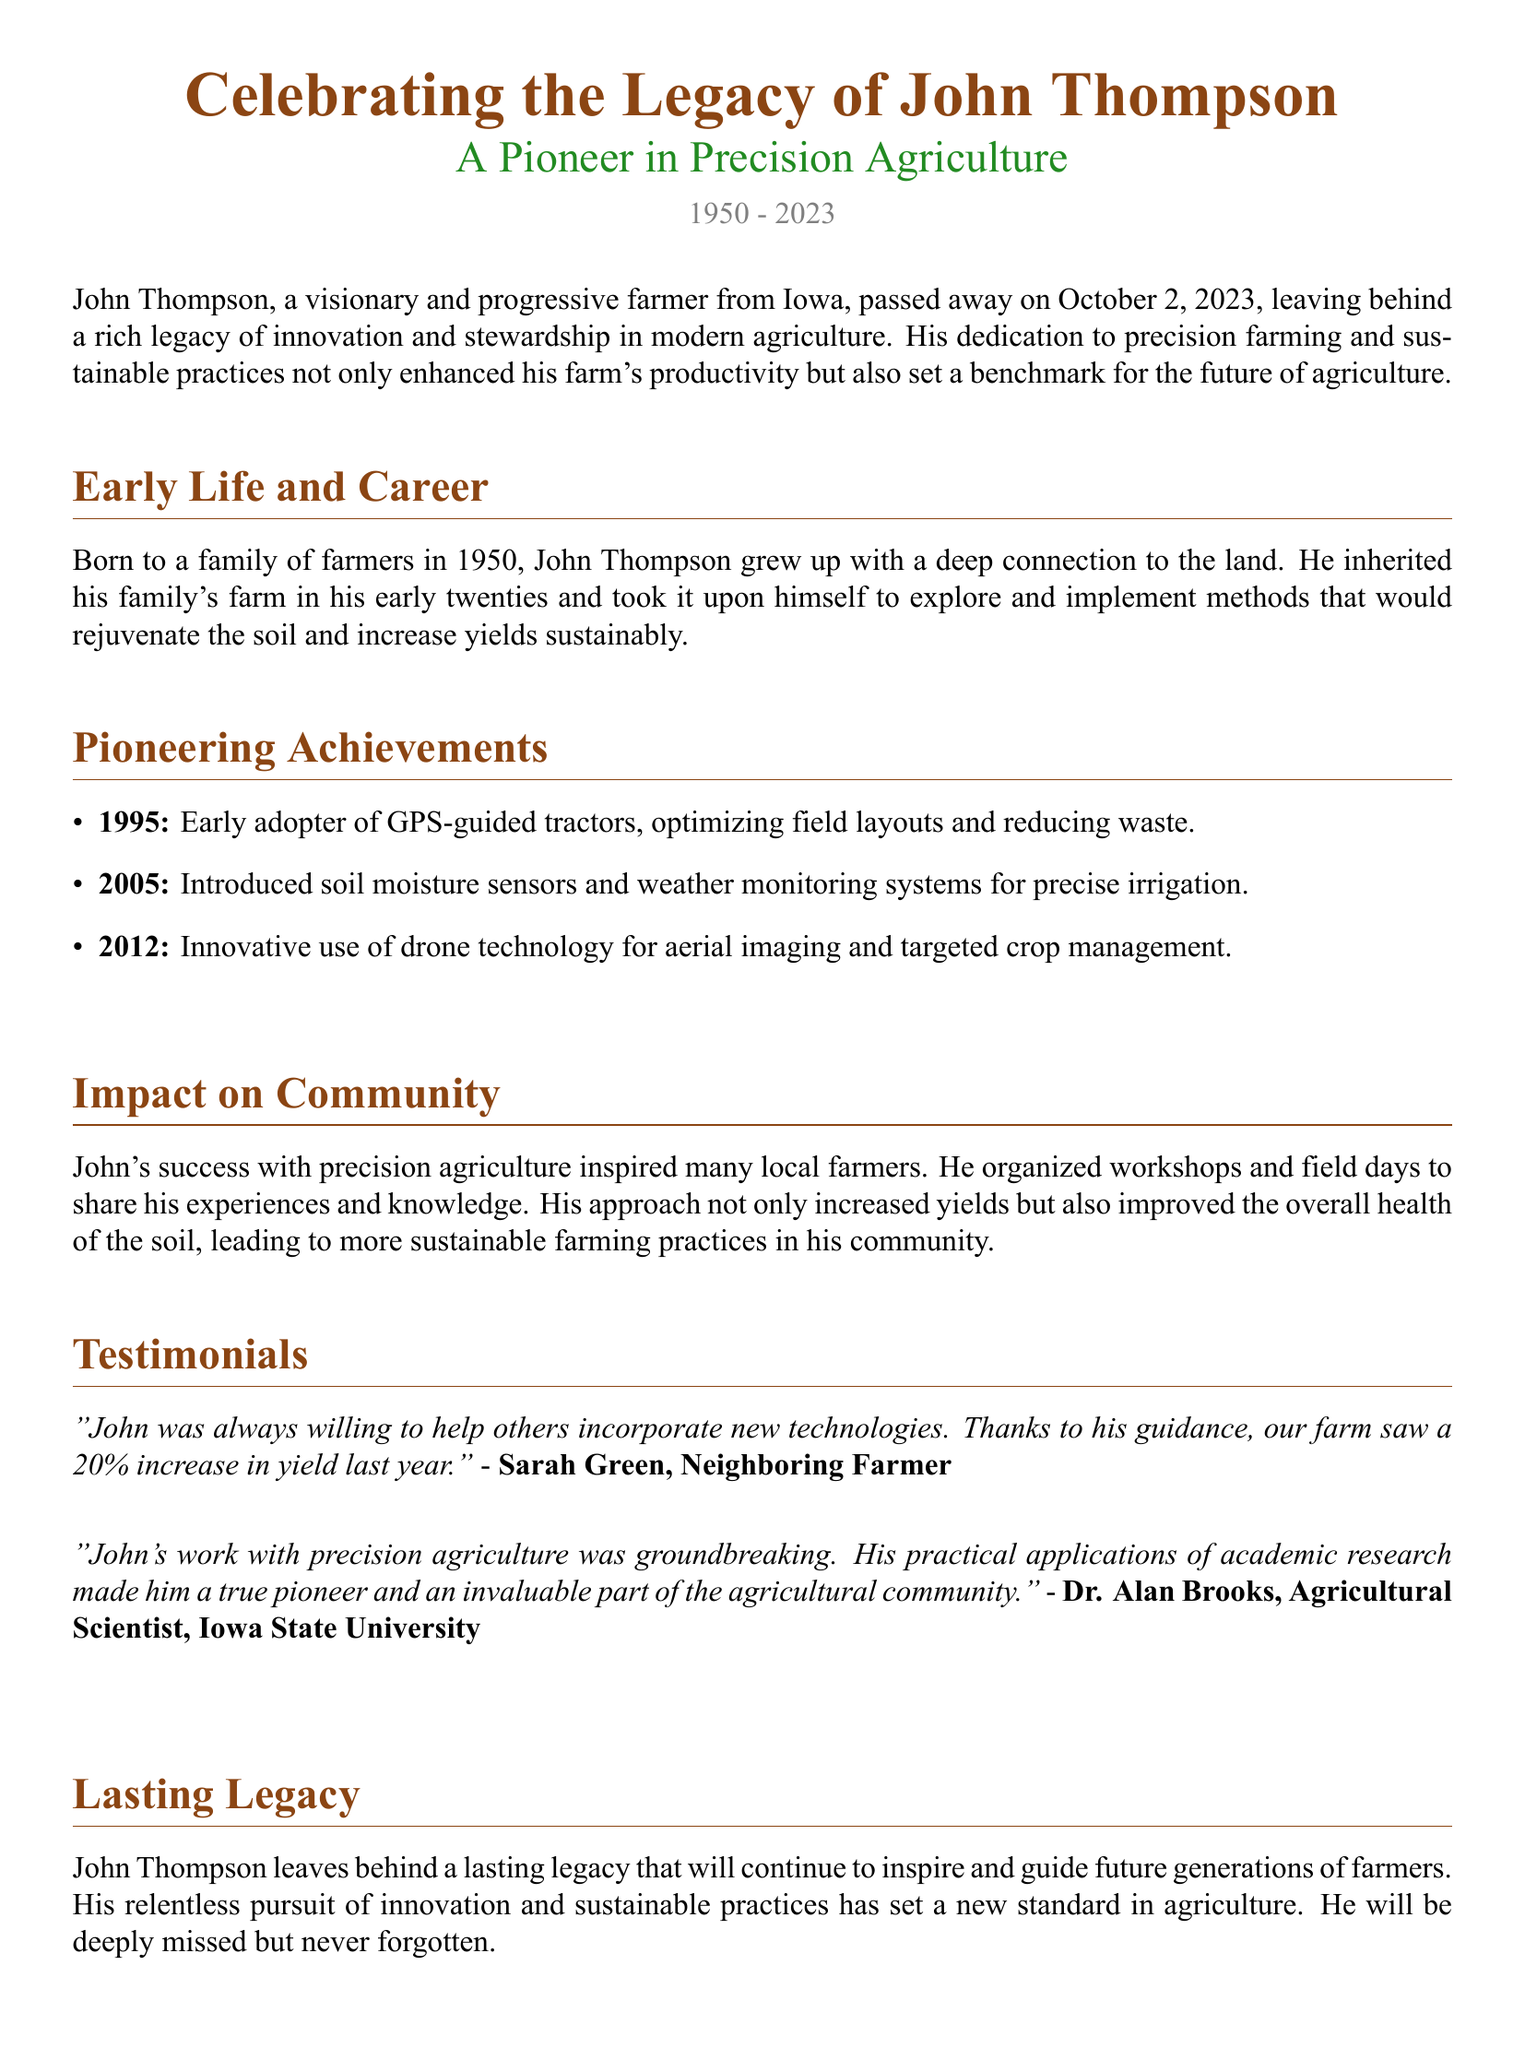What year was John Thompson born? John Thompson was born in 1950, as stated in the document.
Answer: 1950 What is John Thompson’s primary contribution to farming? The document states that his primary contribution was in precision agriculture and sustainable practices.
Answer: Precision agriculture What technology did John first adopt in 1995? The document mentions that in 1995, John was an early adopter of GPS-guided tractors.
Answer: GPS-guided tractors How much did Sarah Green’s farm yield increase due to John’s guidance? According to Sarah Green's testimonial, her farm experienced a 20% increase in yield due to John’s guidance.
Answer: 20% Who provided a testimonial as an agricultural scientist? The document quotes Dr. Alan Brooks, who is identified as an agricultural scientist from Iowa State University.
Answer: Dr. Alan Brooks What is the year of John Thompson's passing? The document states that John Thompson passed away on October 2, 2023.
Answer: 2023 What innovative technology did John utilize in 2012? In 2012, John utilized drone technology for aerial imaging, as stated in the document.
Answer: Drone technology What legacy did John Thompson leave behind? The document highlights that John Thompson leaves behind a lasting legacy that inspires future generations of farmers.
Answer: Lasting legacy In what state did John Thompson operate his farm? The document indicates that John Thompson was a farmer from Iowa.
Answer: Iowa 